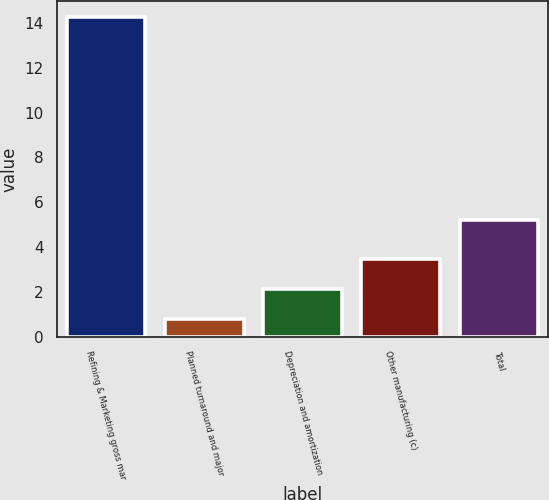<chart> <loc_0><loc_0><loc_500><loc_500><bar_chart><fcel>Refining & Marketing gross mar<fcel>Planned turnaround and major<fcel>Depreciation and amortization<fcel>Other manufacturing (c)<fcel>Total<nl><fcel>14.26<fcel>0.78<fcel>2.13<fcel>3.48<fcel>5.23<nl></chart> 